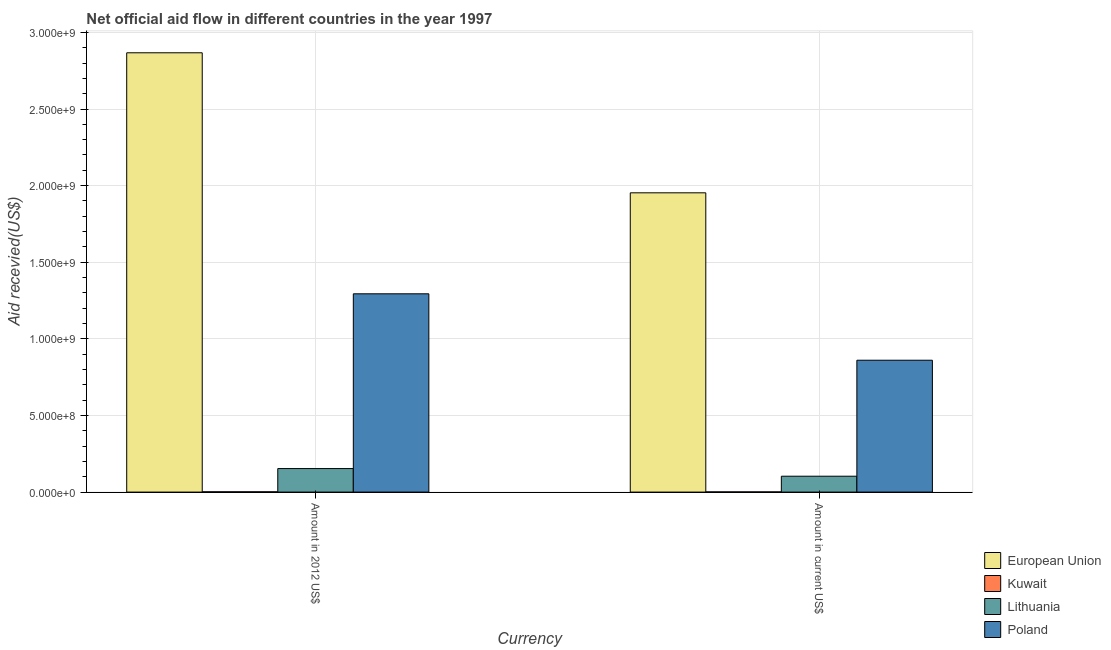How many different coloured bars are there?
Keep it short and to the point. 4. How many groups of bars are there?
Your answer should be very brief. 2. Are the number of bars per tick equal to the number of legend labels?
Make the answer very short. Yes. What is the label of the 2nd group of bars from the left?
Make the answer very short. Amount in current US$. What is the amount of aid received(expressed in 2012 us$) in Poland?
Provide a succinct answer. 1.29e+09. Across all countries, what is the maximum amount of aid received(expressed in us$)?
Provide a succinct answer. 1.95e+09. Across all countries, what is the minimum amount of aid received(expressed in 2012 us$)?
Your response must be concise. 1.85e+06. In which country was the amount of aid received(expressed in us$) maximum?
Provide a succinct answer. European Union. In which country was the amount of aid received(expressed in us$) minimum?
Make the answer very short. Kuwait. What is the total amount of aid received(expressed in us$) in the graph?
Offer a terse response. 2.92e+09. What is the difference between the amount of aid received(expressed in 2012 us$) in Lithuania and that in European Union?
Your response must be concise. -2.71e+09. What is the difference between the amount of aid received(expressed in us$) in Kuwait and the amount of aid received(expressed in 2012 us$) in Poland?
Your answer should be compact. -1.29e+09. What is the average amount of aid received(expressed in 2012 us$) per country?
Provide a succinct answer. 1.08e+09. What is the difference between the amount of aid received(expressed in 2012 us$) and amount of aid received(expressed in us$) in European Union?
Give a very brief answer. 9.14e+08. What is the ratio of the amount of aid received(expressed in 2012 us$) in Poland to that in Kuwait?
Your response must be concise. 699.44. What does the 4th bar from the right in Amount in 2012 US$ represents?
Keep it short and to the point. European Union. How many bars are there?
Provide a succinct answer. 8. What is the difference between two consecutive major ticks on the Y-axis?
Provide a short and direct response. 5.00e+08. Are the values on the major ticks of Y-axis written in scientific E-notation?
Make the answer very short. Yes. How many legend labels are there?
Offer a terse response. 4. How are the legend labels stacked?
Ensure brevity in your answer.  Vertical. What is the title of the graph?
Keep it short and to the point. Net official aid flow in different countries in the year 1997. Does "Burkina Faso" appear as one of the legend labels in the graph?
Provide a succinct answer. No. What is the label or title of the X-axis?
Your answer should be very brief. Currency. What is the label or title of the Y-axis?
Your response must be concise. Aid recevied(US$). What is the Aid recevied(US$) of European Union in Amount in 2012 US$?
Your response must be concise. 2.87e+09. What is the Aid recevied(US$) of Kuwait in Amount in 2012 US$?
Keep it short and to the point. 1.85e+06. What is the Aid recevied(US$) in Lithuania in Amount in 2012 US$?
Give a very brief answer. 1.53e+08. What is the Aid recevied(US$) of Poland in Amount in 2012 US$?
Offer a very short reply. 1.29e+09. What is the Aid recevied(US$) in European Union in Amount in current US$?
Your answer should be compact. 1.95e+09. What is the Aid recevied(US$) of Kuwait in Amount in current US$?
Ensure brevity in your answer.  1.28e+06. What is the Aid recevied(US$) of Lithuania in Amount in current US$?
Keep it short and to the point. 1.04e+08. What is the Aid recevied(US$) in Poland in Amount in current US$?
Your answer should be compact. 8.60e+08. Across all Currency, what is the maximum Aid recevied(US$) in European Union?
Your response must be concise. 2.87e+09. Across all Currency, what is the maximum Aid recevied(US$) in Kuwait?
Ensure brevity in your answer.  1.85e+06. Across all Currency, what is the maximum Aid recevied(US$) of Lithuania?
Provide a succinct answer. 1.53e+08. Across all Currency, what is the maximum Aid recevied(US$) in Poland?
Offer a very short reply. 1.29e+09. Across all Currency, what is the minimum Aid recevied(US$) in European Union?
Give a very brief answer. 1.95e+09. Across all Currency, what is the minimum Aid recevied(US$) of Kuwait?
Offer a terse response. 1.28e+06. Across all Currency, what is the minimum Aid recevied(US$) in Lithuania?
Give a very brief answer. 1.04e+08. Across all Currency, what is the minimum Aid recevied(US$) of Poland?
Your answer should be very brief. 8.60e+08. What is the total Aid recevied(US$) of European Union in the graph?
Your answer should be compact. 4.82e+09. What is the total Aid recevied(US$) in Kuwait in the graph?
Provide a succinct answer. 3.13e+06. What is the total Aid recevied(US$) of Lithuania in the graph?
Your answer should be very brief. 2.57e+08. What is the total Aid recevied(US$) of Poland in the graph?
Ensure brevity in your answer.  2.15e+09. What is the difference between the Aid recevied(US$) of European Union in Amount in 2012 US$ and that in Amount in current US$?
Offer a terse response. 9.14e+08. What is the difference between the Aid recevied(US$) of Kuwait in Amount in 2012 US$ and that in Amount in current US$?
Provide a succinct answer. 5.70e+05. What is the difference between the Aid recevied(US$) in Lithuania in Amount in 2012 US$ and that in Amount in current US$?
Provide a succinct answer. 4.99e+07. What is the difference between the Aid recevied(US$) of Poland in Amount in 2012 US$ and that in Amount in current US$?
Your answer should be very brief. 4.33e+08. What is the difference between the Aid recevied(US$) in European Union in Amount in 2012 US$ and the Aid recevied(US$) in Kuwait in Amount in current US$?
Offer a very short reply. 2.87e+09. What is the difference between the Aid recevied(US$) in European Union in Amount in 2012 US$ and the Aid recevied(US$) in Lithuania in Amount in current US$?
Offer a very short reply. 2.76e+09. What is the difference between the Aid recevied(US$) of European Union in Amount in 2012 US$ and the Aid recevied(US$) of Poland in Amount in current US$?
Your response must be concise. 2.01e+09. What is the difference between the Aid recevied(US$) in Kuwait in Amount in 2012 US$ and the Aid recevied(US$) in Lithuania in Amount in current US$?
Provide a short and direct response. -1.02e+08. What is the difference between the Aid recevied(US$) in Kuwait in Amount in 2012 US$ and the Aid recevied(US$) in Poland in Amount in current US$?
Ensure brevity in your answer.  -8.59e+08. What is the difference between the Aid recevied(US$) in Lithuania in Amount in 2012 US$ and the Aid recevied(US$) in Poland in Amount in current US$?
Your response must be concise. -7.07e+08. What is the average Aid recevied(US$) in European Union per Currency?
Ensure brevity in your answer.  2.41e+09. What is the average Aid recevied(US$) in Kuwait per Currency?
Provide a succinct answer. 1.56e+06. What is the average Aid recevied(US$) in Lithuania per Currency?
Offer a terse response. 1.29e+08. What is the average Aid recevied(US$) in Poland per Currency?
Offer a terse response. 1.08e+09. What is the difference between the Aid recevied(US$) of European Union and Aid recevied(US$) of Kuwait in Amount in 2012 US$?
Keep it short and to the point. 2.86e+09. What is the difference between the Aid recevied(US$) in European Union and Aid recevied(US$) in Lithuania in Amount in 2012 US$?
Your answer should be compact. 2.71e+09. What is the difference between the Aid recevied(US$) in European Union and Aid recevied(US$) in Poland in Amount in 2012 US$?
Provide a succinct answer. 1.57e+09. What is the difference between the Aid recevied(US$) in Kuwait and Aid recevied(US$) in Lithuania in Amount in 2012 US$?
Your response must be concise. -1.52e+08. What is the difference between the Aid recevied(US$) in Kuwait and Aid recevied(US$) in Poland in Amount in 2012 US$?
Give a very brief answer. -1.29e+09. What is the difference between the Aid recevied(US$) in Lithuania and Aid recevied(US$) in Poland in Amount in 2012 US$?
Your response must be concise. -1.14e+09. What is the difference between the Aid recevied(US$) of European Union and Aid recevied(US$) of Kuwait in Amount in current US$?
Make the answer very short. 1.95e+09. What is the difference between the Aid recevied(US$) of European Union and Aid recevied(US$) of Lithuania in Amount in current US$?
Offer a very short reply. 1.85e+09. What is the difference between the Aid recevied(US$) in European Union and Aid recevied(US$) in Poland in Amount in current US$?
Your answer should be compact. 1.09e+09. What is the difference between the Aid recevied(US$) in Kuwait and Aid recevied(US$) in Lithuania in Amount in current US$?
Ensure brevity in your answer.  -1.02e+08. What is the difference between the Aid recevied(US$) in Kuwait and Aid recevied(US$) in Poland in Amount in current US$?
Provide a short and direct response. -8.59e+08. What is the difference between the Aid recevied(US$) of Lithuania and Aid recevied(US$) of Poland in Amount in current US$?
Your answer should be very brief. -7.57e+08. What is the ratio of the Aid recevied(US$) in European Union in Amount in 2012 US$ to that in Amount in current US$?
Make the answer very short. 1.47. What is the ratio of the Aid recevied(US$) in Kuwait in Amount in 2012 US$ to that in Amount in current US$?
Offer a terse response. 1.45. What is the ratio of the Aid recevied(US$) of Lithuania in Amount in 2012 US$ to that in Amount in current US$?
Ensure brevity in your answer.  1.48. What is the ratio of the Aid recevied(US$) in Poland in Amount in 2012 US$ to that in Amount in current US$?
Your response must be concise. 1.5. What is the difference between the highest and the second highest Aid recevied(US$) of European Union?
Your answer should be very brief. 9.14e+08. What is the difference between the highest and the second highest Aid recevied(US$) of Kuwait?
Your answer should be very brief. 5.70e+05. What is the difference between the highest and the second highest Aid recevied(US$) in Lithuania?
Your response must be concise. 4.99e+07. What is the difference between the highest and the second highest Aid recevied(US$) of Poland?
Provide a short and direct response. 4.33e+08. What is the difference between the highest and the lowest Aid recevied(US$) in European Union?
Your response must be concise. 9.14e+08. What is the difference between the highest and the lowest Aid recevied(US$) in Kuwait?
Provide a succinct answer. 5.70e+05. What is the difference between the highest and the lowest Aid recevied(US$) of Lithuania?
Keep it short and to the point. 4.99e+07. What is the difference between the highest and the lowest Aid recevied(US$) in Poland?
Your answer should be compact. 4.33e+08. 